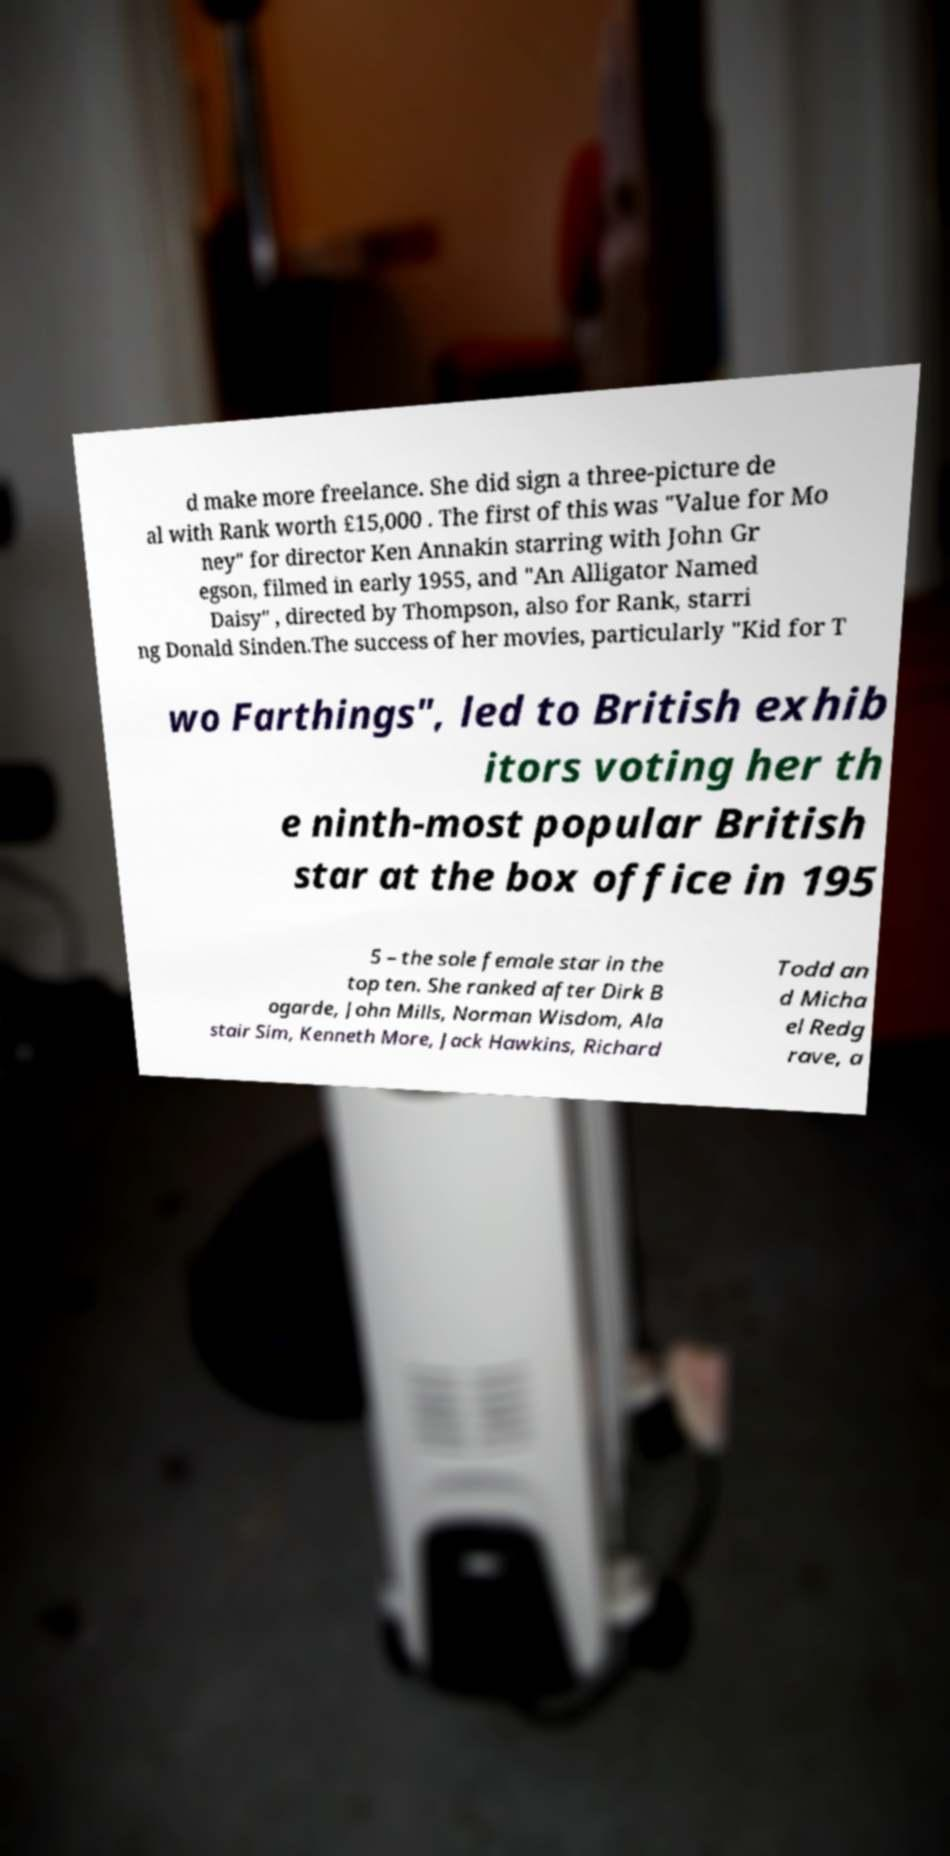Could you extract and type out the text from this image? d make more freelance. She did sign a three-picture de al with Rank worth £15,000 . The first of this was "Value for Mo ney" for director Ken Annakin starring with John Gr egson, filmed in early 1955, and "An Alligator Named Daisy" , directed by Thompson, also for Rank, starri ng Donald Sinden.The success of her movies, particularly "Kid for T wo Farthings", led to British exhib itors voting her th e ninth-most popular British star at the box office in 195 5 – the sole female star in the top ten. She ranked after Dirk B ogarde, John Mills, Norman Wisdom, Ala stair Sim, Kenneth More, Jack Hawkins, Richard Todd an d Micha el Redg rave, a 